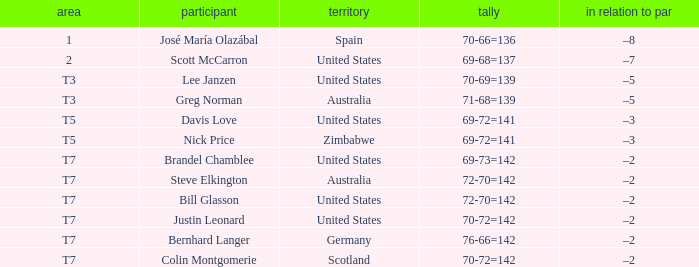Name the Player who has a Place of t7 in Country of united states? Brandel Chamblee, Bill Glasson, Justin Leonard. Parse the full table. {'header': ['area', 'participant', 'territory', 'tally', 'in relation to par'], 'rows': [['1', 'José María Olazábal', 'Spain', '70-66=136', '–8'], ['2', 'Scott McCarron', 'United States', '69-68=137', '–7'], ['T3', 'Lee Janzen', 'United States', '70-69=139', '–5'], ['T3', 'Greg Norman', 'Australia', '71-68=139', '–5'], ['T5', 'Davis Love', 'United States', '69-72=141', '–3'], ['T5', 'Nick Price', 'Zimbabwe', '69-72=141', '–3'], ['T7', 'Brandel Chamblee', 'United States', '69-73=142', '–2'], ['T7', 'Steve Elkington', 'Australia', '72-70=142', '–2'], ['T7', 'Bill Glasson', 'United States', '72-70=142', '–2'], ['T7', 'Justin Leonard', 'United States', '70-72=142', '–2'], ['T7', 'Bernhard Langer', 'Germany', '76-66=142', '–2'], ['T7', 'Colin Montgomerie', 'Scotland', '70-72=142', '–2']]} 